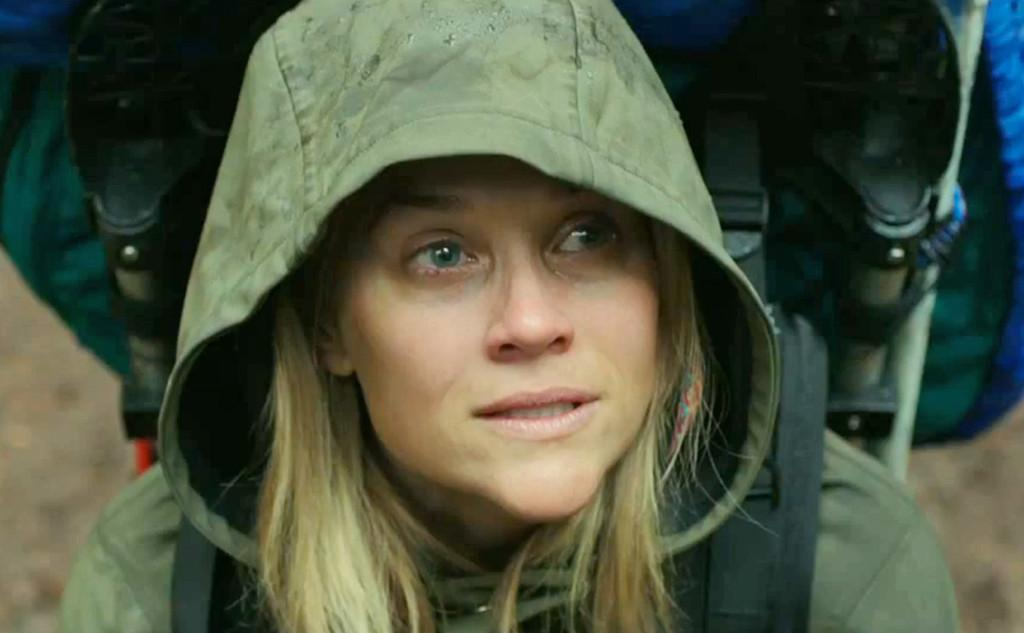Who is the main subject in the image? There is a woman in the image. What is the woman wearing? The woman is wearing a hoodie. What is the woman carrying in the image? The woman is carrying a backpack. Can you describe the background of the image? The background of the image has a blurred view. Can you see a key hanging from the tree in the image? There is no tree or key present in the image. Is there a snake visible in the image? There is no snake present in the image. 